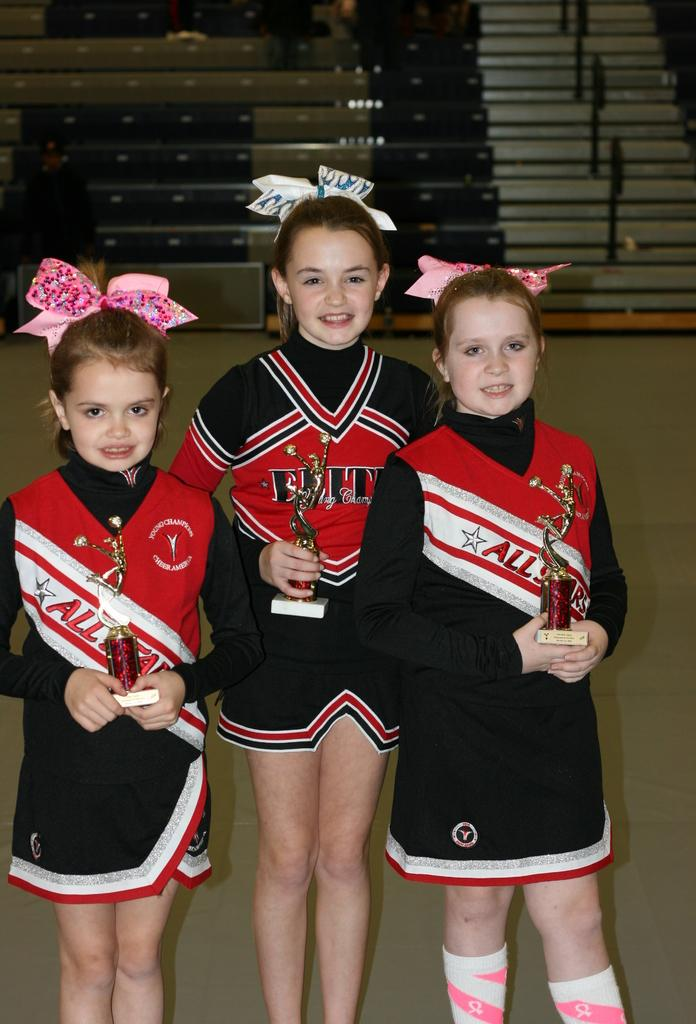Provide a one-sentence caption for the provided image. three cheerleaders the with names All on them. 